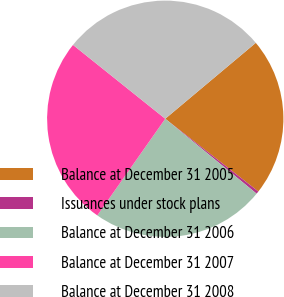<chart> <loc_0><loc_0><loc_500><loc_500><pie_chart><fcel>Balance at December 31 2005<fcel>Issuances under stock plans<fcel>Balance at December 31 2006<fcel>Balance at December 31 2007<fcel>Balance at December 31 2008<nl><fcel>21.66%<fcel>0.38%<fcel>23.82%<fcel>25.99%<fcel>28.15%<nl></chart> 